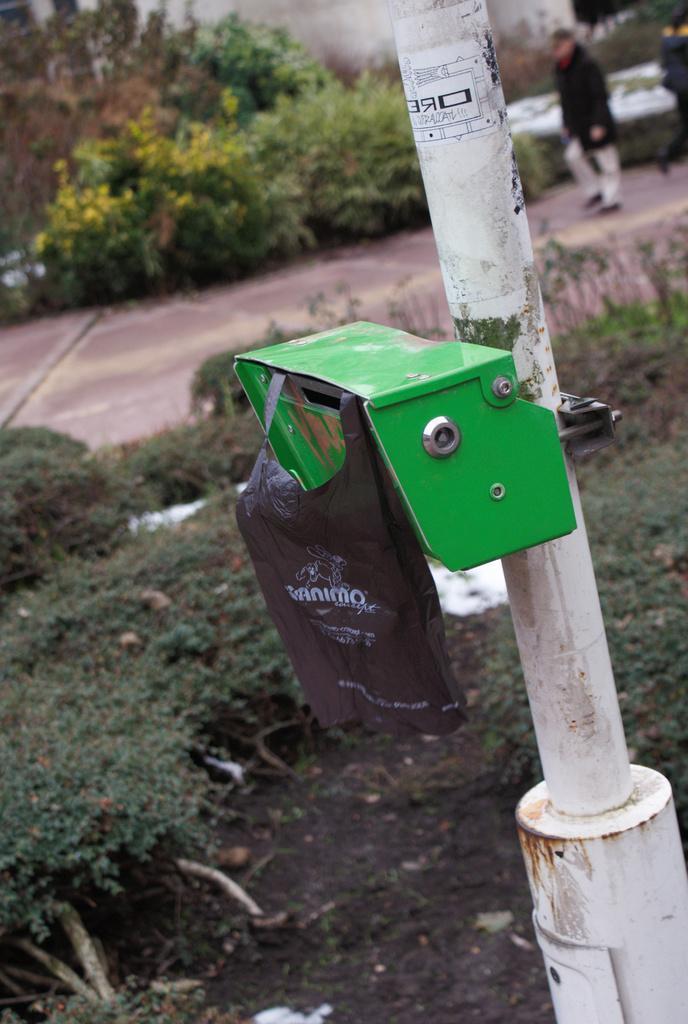In one or two sentences, can you explain what this image depicts? In the center of the image, we can see a box and a bag to a pole and in the background, there are trees, plants and we can see some people walking on the road. 